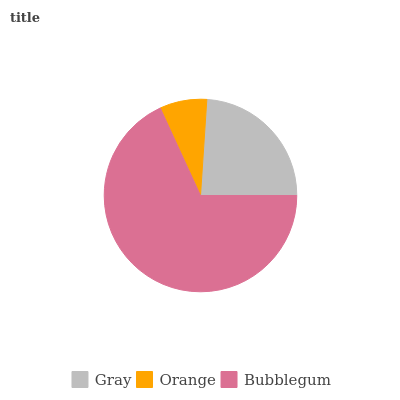Is Orange the minimum?
Answer yes or no. Yes. Is Bubblegum the maximum?
Answer yes or no. Yes. Is Bubblegum the minimum?
Answer yes or no. No. Is Orange the maximum?
Answer yes or no. No. Is Bubblegum greater than Orange?
Answer yes or no. Yes. Is Orange less than Bubblegum?
Answer yes or no. Yes. Is Orange greater than Bubblegum?
Answer yes or no. No. Is Bubblegum less than Orange?
Answer yes or no. No. Is Gray the high median?
Answer yes or no. Yes. Is Gray the low median?
Answer yes or no. Yes. Is Orange the high median?
Answer yes or no. No. Is Bubblegum the low median?
Answer yes or no. No. 